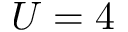<formula> <loc_0><loc_0><loc_500><loc_500>U = 4</formula> 